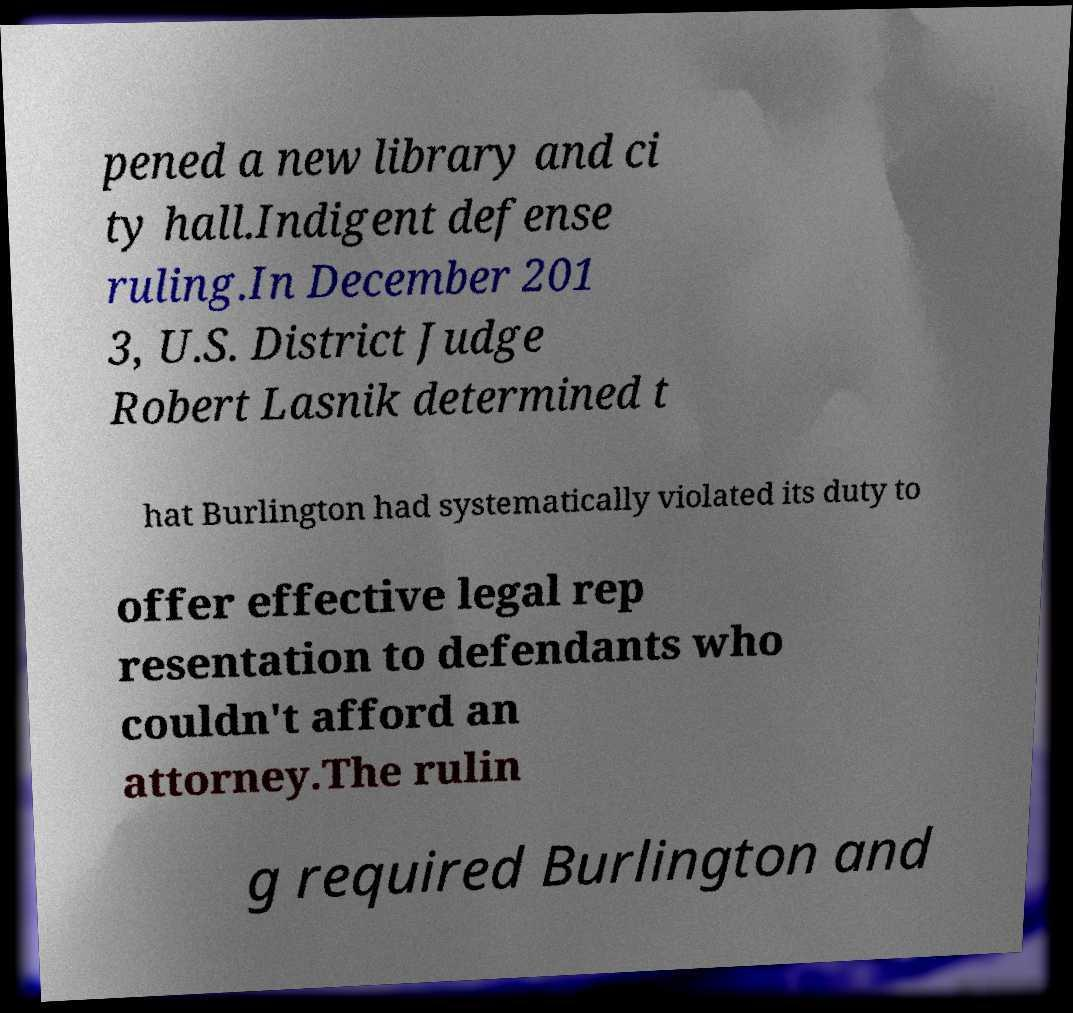Could you assist in decoding the text presented in this image and type it out clearly? pened a new library and ci ty hall.Indigent defense ruling.In December 201 3, U.S. District Judge Robert Lasnik determined t hat Burlington had systematically violated its duty to offer effective legal rep resentation to defendants who couldn't afford an attorney.The rulin g required Burlington and 